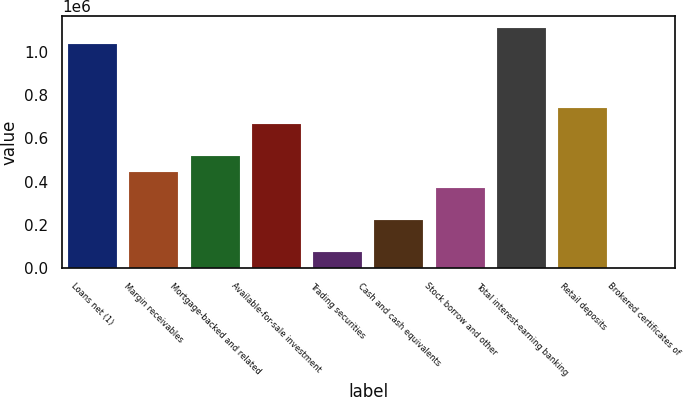Convert chart. <chart><loc_0><loc_0><loc_500><loc_500><bar_chart><fcel>Loans net (1)<fcel>Margin receivables<fcel>Mortgage-backed and related<fcel>Available-for-sale investment<fcel>Trading securities<fcel>Cash and cash equivalents<fcel>Stock borrow and other<fcel>Total interest-earning banking<fcel>Retail deposits<fcel>Brokered certificates of<nl><fcel>1.03498e+06<fcel>444194<fcel>518042<fcel>665738<fcel>74954.9<fcel>222651<fcel>370346<fcel>1.10883e+06<fcel>739586<fcel>1107<nl></chart> 